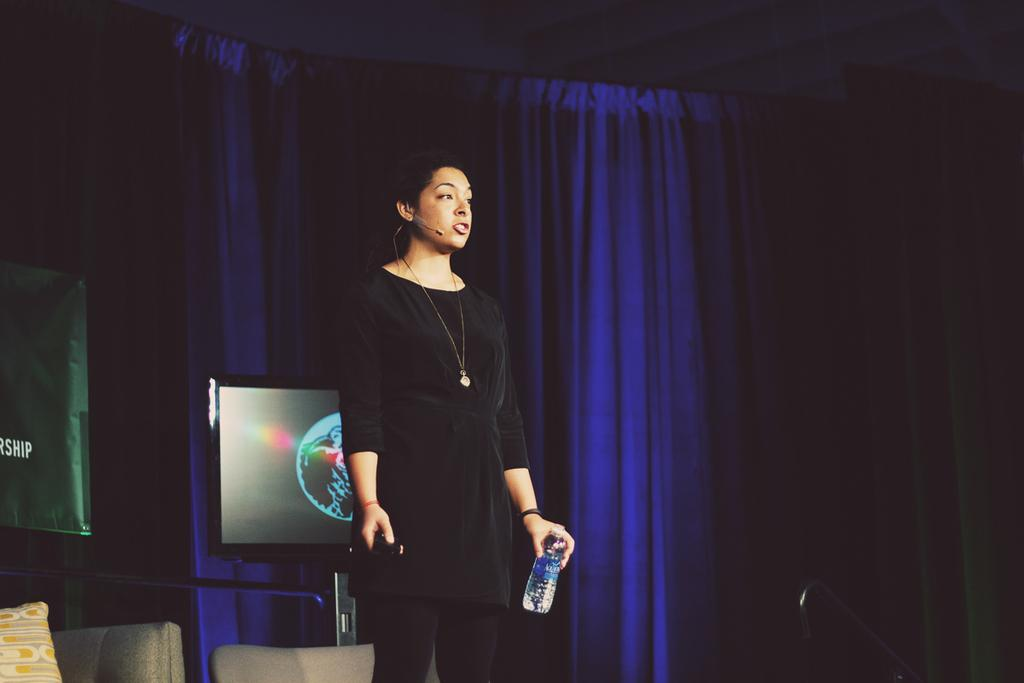What is the woman in the image doing? The woman is standing in the image. What is the woman holding in the image? The woman is holding a bottle. What can be seen in the background of the image? There is a blue color curtain in the background. What is present in the foreground of the image? There is a microphone in the foreground. How does the woman's daughter feel about the bomb in the image? There is no daughter or bomb present in the image. 